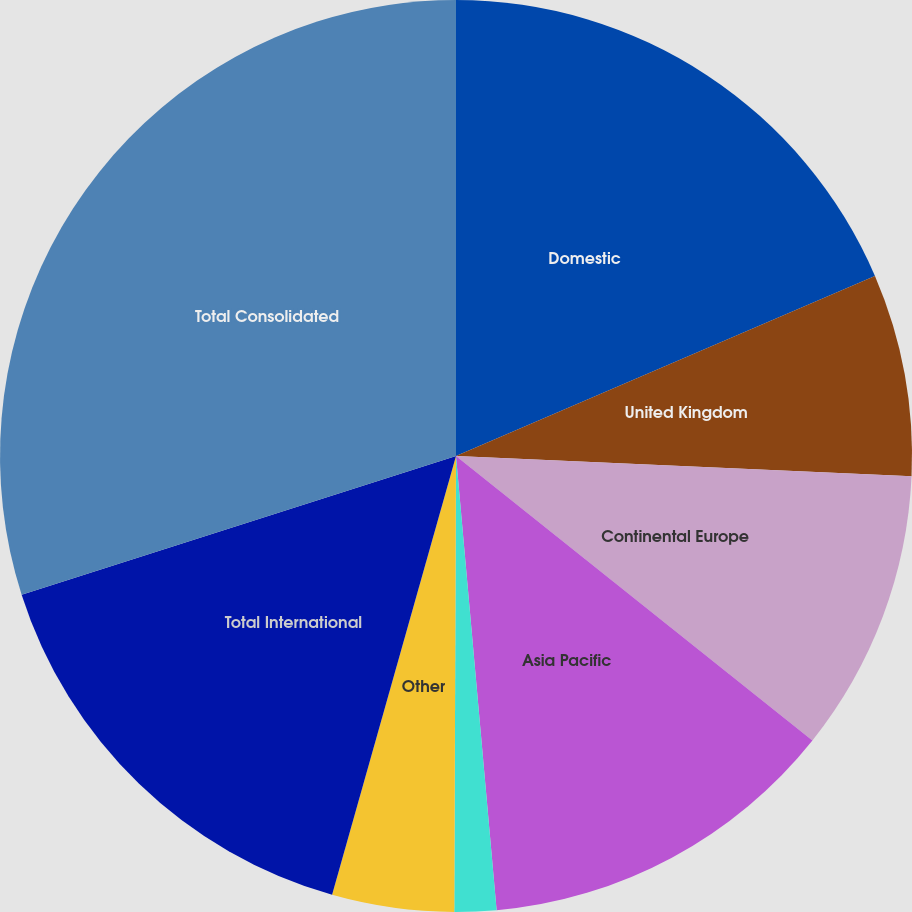Convert chart. <chart><loc_0><loc_0><loc_500><loc_500><pie_chart><fcel>Domestic<fcel>United Kingdom<fcel>Continental Europe<fcel>Asia Pacific<fcel>Latin America<fcel>Other<fcel>Total International<fcel>Total Consolidated<nl><fcel>18.54%<fcel>7.17%<fcel>10.01%<fcel>12.86%<fcel>1.48%<fcel>4.32%<fcel>15.7%<fcel>29.92%<nl></chart> 